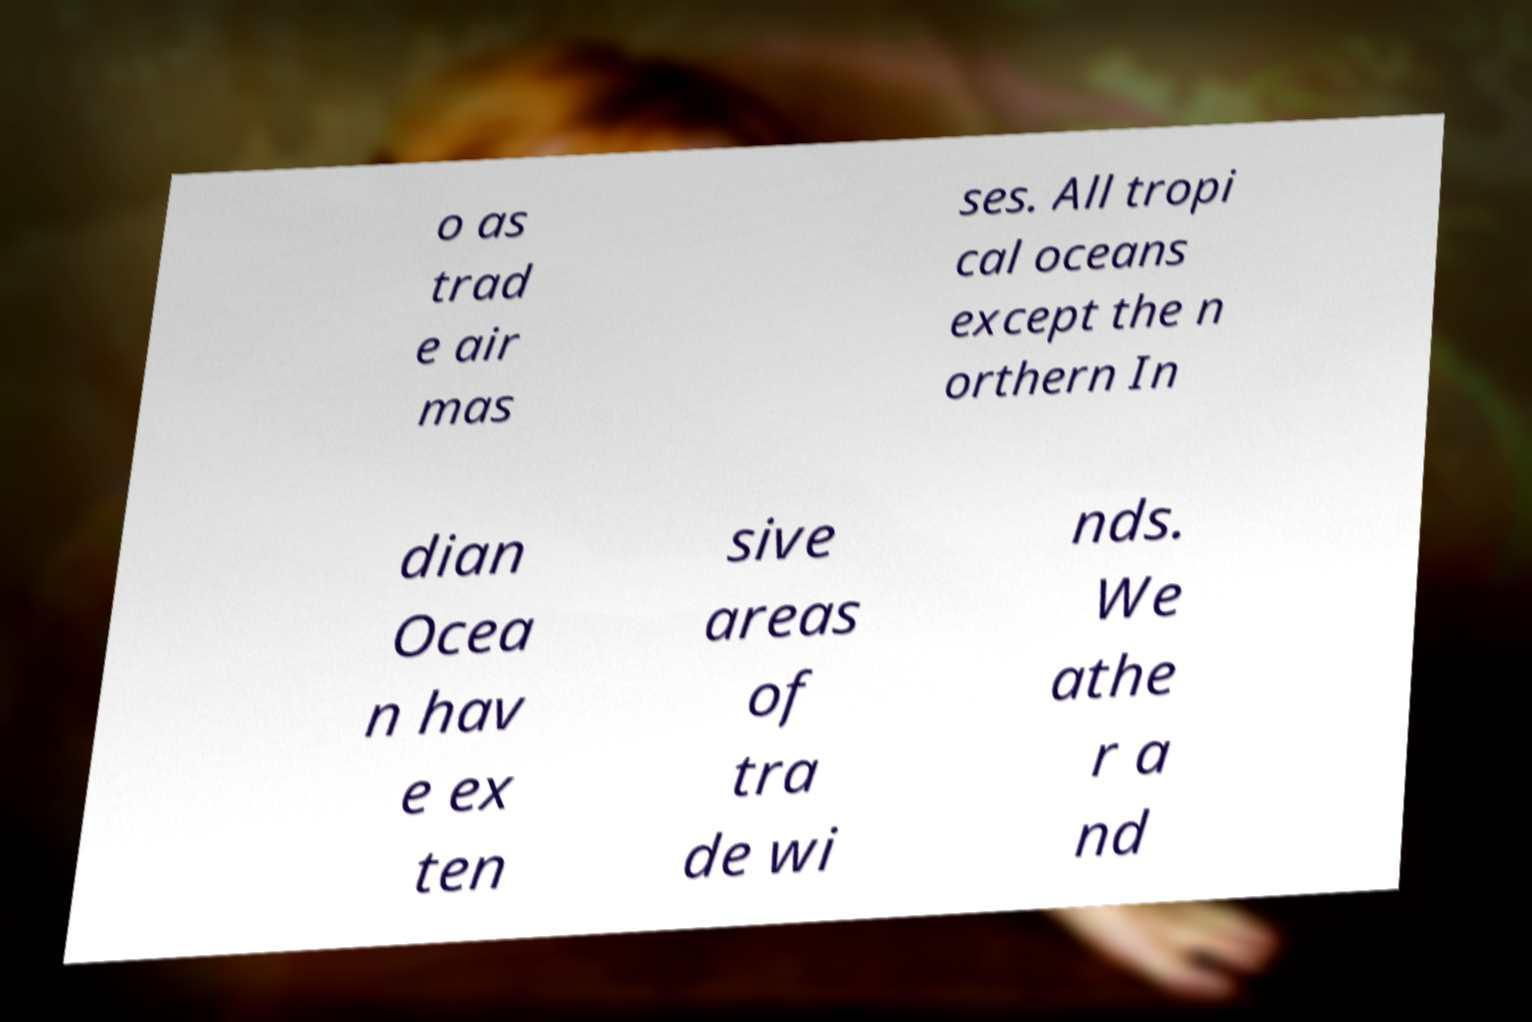Could you assist in decoding the text presented in this image and type it out clearly? o as trad e air mas ses. All tropi cal oceans except the n orthern In dian Ocea n hav e ex ten sive areas of tra de wi nds. We athe r a nd 